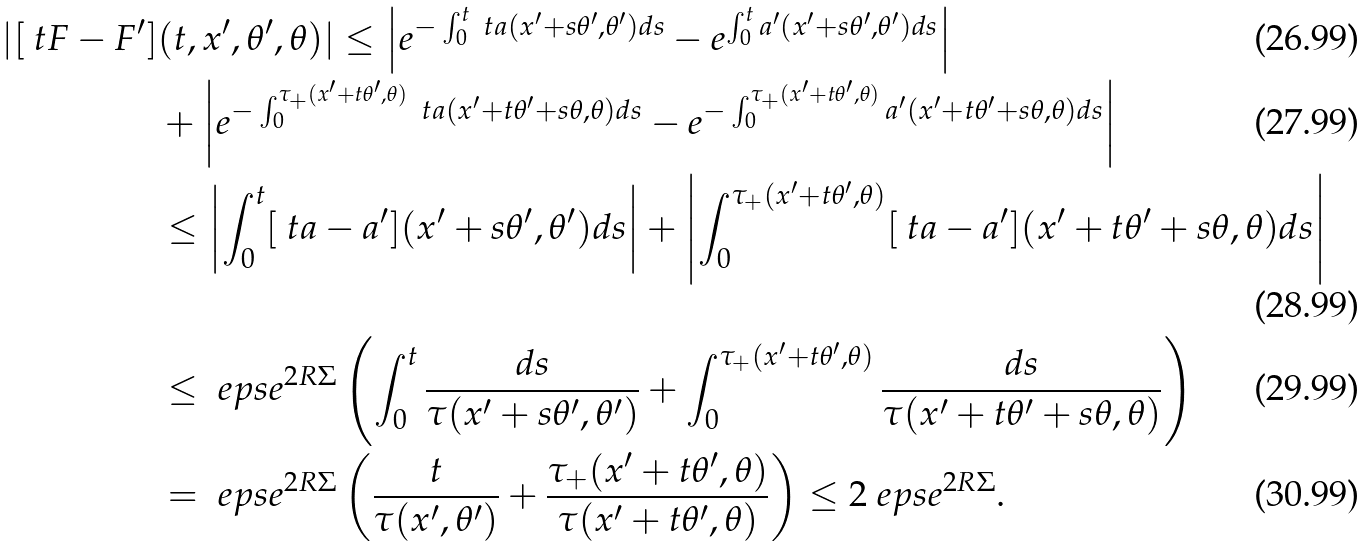<formula> <loc_0><loc_0><loc_500><loc_500>| [ \ t F - F ^ { \prime } ] & ( t , x ^ { \prime } , \theta ^ { \prime } , \theta ) | \leq \left | e ^ { - \int _ { 0 } ^ { t } \ t a ( x ^ { \prime } + s \theta ^ { \prime } , \theta ^ { \prime } ) d s } - e ^ { \int _ { 0 } ^ { t } a ^ { \prime } ( x ^ { \prime } + s \theta ^ { \prime } , \theta ^ { \prime } ) d s } \right | \\ & + \left | e ^ { - \int _ { 0 } ^ { \tau _ { + } ( x ^ { \prime } + t \theta ^ { \prime } , \theta ) } \ t a ( x ^ { \prime } + t \theta ^ { \prime } + s \theta , \theta ) d s } - e ^ { - \int _ { 0 } ^ { \tau _ { + } ( x ^ { \prime } + t \theta ^ { \prime } , \theta ) } a ^ { \prime } ( x ^ { \prime } + t \theta ^ { \prime } + s \theta , \theta ) d s } \right | \\ & \leq \left | \int _ { 0 } ^ { t } [ \ t a - a ^ { \prime } ] ( x ^ { \prime } + s \theta ^ { \prime } , \theta ^ { \prime } ) d s \right | + \left | \int _ { 0 } ^ { \tau _ { + } ( x ^ { \prime } + t \theta ^ { \prime } , \theta ) } [ \ t a - a ^ { \prime } ] ( x ^ { \prime } + t \theta ^ { \prime } + s \theta , \theta ) d s \right | \\ & \leq \ e p s e ^ { 2 R \Sigma } \left ( \int _ { 0 } ^ { t } \frac { d s } { \tau ( x ^ { \prime } + s \theta ^ { \prime } , \theta ^ { \prime } ) } + \int _ { 0 } ^ { \tau _ { + } ( x ^ { \prime } + t \theta ^ { \prime } , \theta ) } \frac { d s } { \tau ( x ^ { \prime } + t \theta ^ { \prime } + s \theta , \theta ) } \right ) \\ & = \ e p s e ^ { 2 R \Sigma } \left ( \frac { t } { \tau ( x ^ { \prime } , \theta ^ { \prime } ) } + \frac { \tau _ { + } ( x ^ { \prime } + t \theta ^ { \prime } , \theta ) } { \tau ( x ^ { \prime } + t \theta ^ { \prime } , \theta ) } \right ) \leq 2 \ e p s e ^ { 2 R \Sigma } .</formula> 